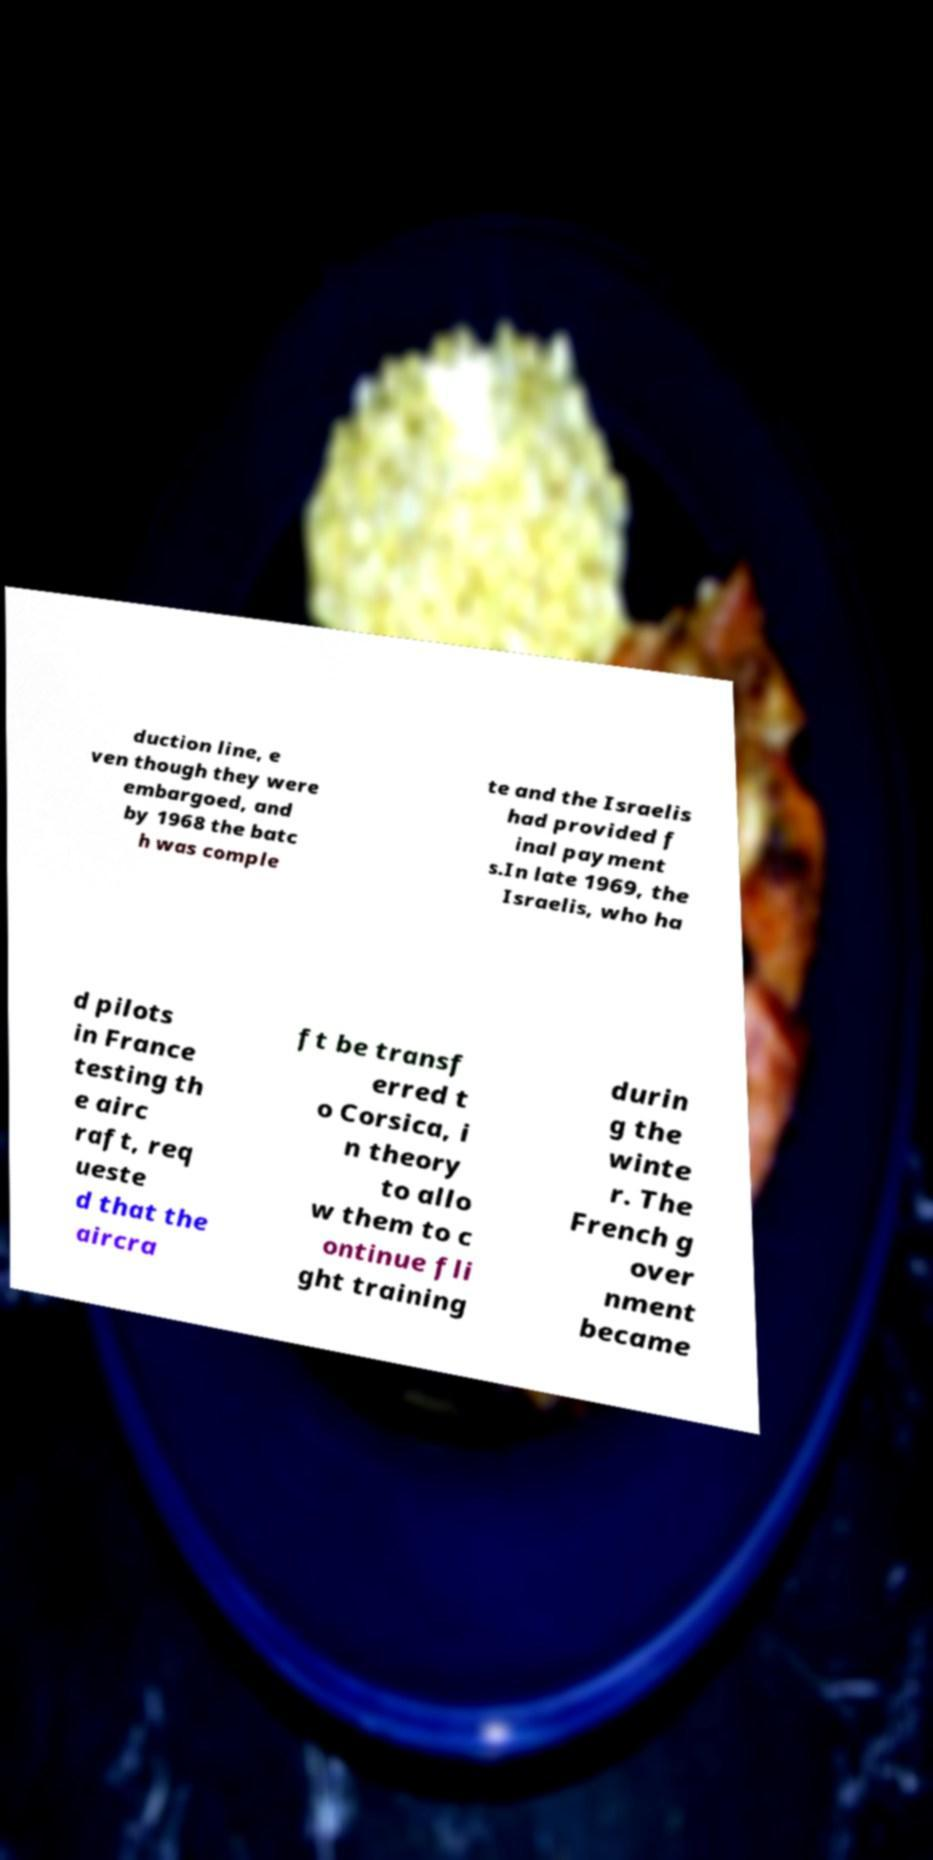There's text embedded in this image that I need extracted. Can you transcribe it verbatim? duction line, e ven though they were embargoed, and by 1968 the batc h was comple te and the Israelis had provided f inal payment s.In late 1969, the Israelis, who ha d pilots in France testing th e airc raft, req ueste d that the aircra ft be transf erred t o Corsica, i n theory to allo w them to c ontinue fli ght training durin g the winte r. The French g over nment became 